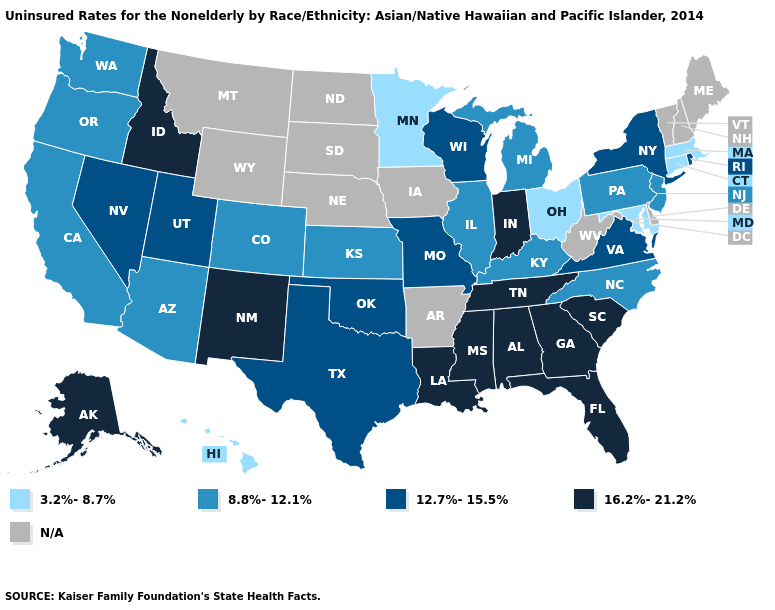Name the states that have a value in the range N/A?
Write a very short answer. Arkansas, Delaware, Iowa, Maine, Montana, Nebraska, New Hampshire, North Dakota, South Dakota, Vermont, West Virginia, Wyoming. Among the states that border Louisiana , which have the lowest value?
Concise answer only. Texas. Among the states that border North Carolina , which have the highest value?
Concise answer only. Georgia, South Carolina, Tennessee. What is the value of Iowa?
Quick response, please. N/A. Among the states that border Ohio , does Indiana have the highest value?
Answer briefly. Yes. What is the value of New Jersey?
Be succinct. 8.8%-12.1%. Name the states that have a value in the range 12.7%-15.5%?
Keep it brief. Missouri, Nevada, New York, Oklahoma, Rhode Island, Texas, Utah, Virginia, Wisconsin. What is the highest value in the USA?
Concise answer only. 16.2%-21.2%. Name the states that have a value in the range 3.2%-8.7%?
Be succinct. Connecticut, Hawaii, Maryland, Massachusetts, Minnesota, Ohio. Does the map have missing data?
Quick response, please. Yes. What is the highest value in the USA?
Quick response, please. 16.2%-21.2%. Which states have the lowest value in the USA?
Quick response, please. Connecticut, Hawaii, Maryland, Massachusetts, Minnesota, Ohio. Does Minnesota have the lowest value in the MidWest?
Concise answer only. Yes. 